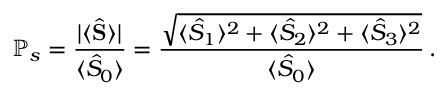<formula> <loc_0><loc_0><loc_500><loc_500>\mathbb { P } _ { s } = \frac { | \langle \hat { S } \rangle | } { \langle \hat { S } _ { 0 } \rangle } = \frac { \sqrt { \langle \hat { S } _ { 1 } \rangle ^ { 2 } + \langle \hat { S } _ { 2 } \rangle ^ { 2 } + \langle \hat { S } _ { 3 } \rangle ^ { 2 } } } { \langle \hat { S } _ { 0 } \rangle } \, .</formula> 